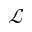<formula> <loc_0><loc_0><loc_500><loc_500>\ m a t h s c r { L }</formula> 